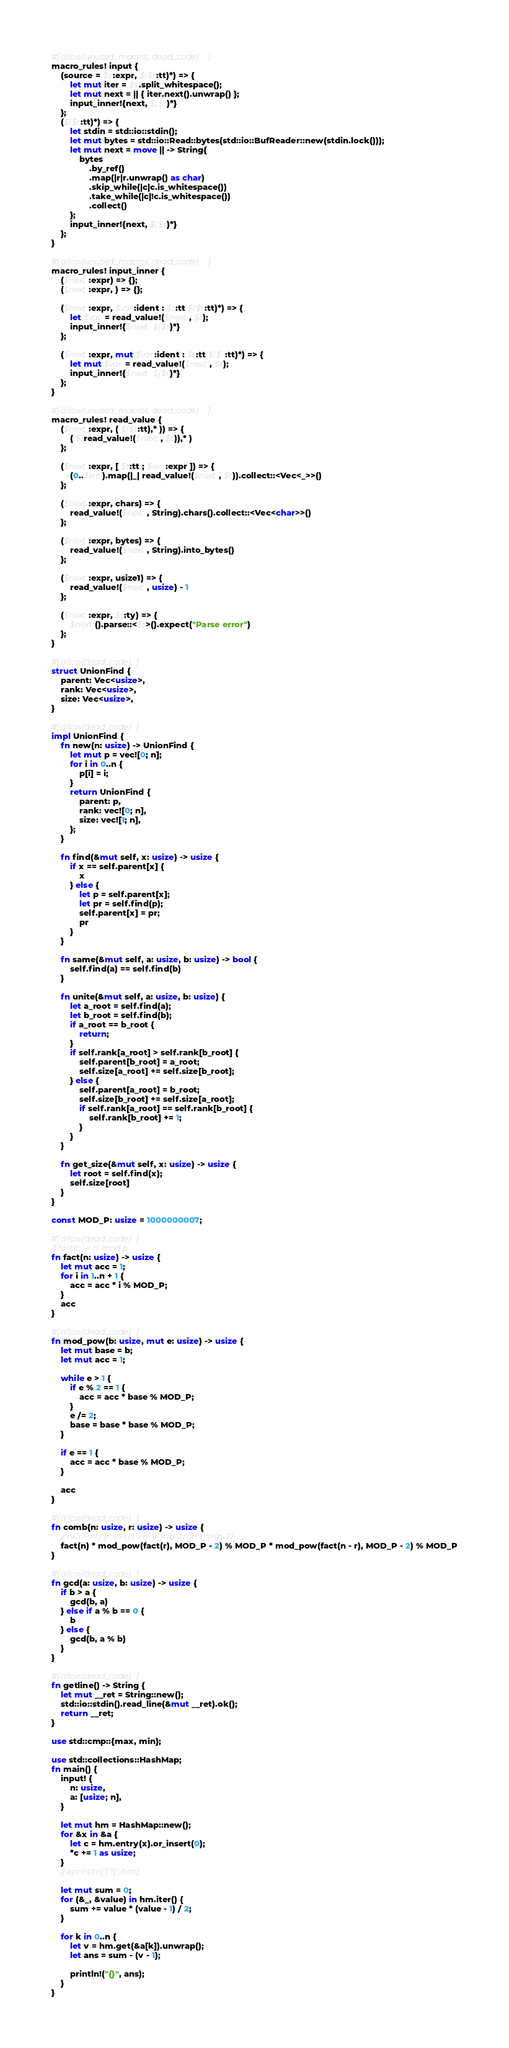Convert code to text. <code><loc_0><loc_0><loc_500><loc_500><_Rust_>#[allow(unused_macros, dead_code)]
macro_rules! input {
    (source = $s:expr, $($r:tt)*) => {
        let mut iter = $s.split_whitespace();
        let mut next = || { iter.next().unwrap() };
        input_inner!{next, $($r)*}
    };
    ($($r:tt)*) => {
        let stdin = std::io::stdin();
        let mut bytes = std::io::Read::bytes(std::io::BufReader::new(stdin.lock()));
        let mut next = move || -> String{
            bytes
                .by_ref()
                .map(|r|r.unwrap() as char)
                .skip_while(|c|c.is_whitespace())
                .take_while(|c|!c.is_whitespace())
                .collect()
        };
        input_inner!{next, $($r)*}
    };
}

#[allow(unused_macros, dead_code)]
macro_rules! input_inner {
    ($next:expr) => {};
    ($next:expr, ) => {};

    ($next:expr, $var:ident : $t:tt $($r:tt)*) => {
        let $var = read_value!($next, $t);
        input_inner!{$next $($r)*}
    };

    ($next:expr, mut $var:ident : $t:tt $($r:tt)*) => {
        let mut $var = read_value!($next, $t);
        input_inner!{$next $($r)*}
    };
}

#[allow(unused_macros, dead_code)]
macro_rules! read_value {
    ($next:expr, ( $($t:tt),* )) => {
        ( $(read_value!($next, $t)),* )
    };

    ($next:expr, [ $t:tt ; $len:expr ]) => {
        (0..$len).map(|_| read_value!($next, $t)).collect::<Vec<_>>()
    };

    ($next:expr, chars) => {
        read_value!($next, String).chars().collect::<Vec<char>>()
    };

    ($next:expr, bytes) => {
        read_value!($next, String).into_bytes()
    };

    ($next:expr, usize1) => {
        read_value!($next, usize) - 1
    };

    ($next:expr, $t:ty) => {
        $next().parse::<$t>().expect("Parse error")
    };
}

#[allow(dead_code)]
struct UnionFind {
    parent: Vec<usize>,
    rank: Vec<usize>,
    size: Vec<usize>,
}

#[allow(dead_code)]
impl UnionFind {
    fn new(n: usize) -> UnionFind {
        let mut p = vec![0; n];
        for i in 0..n {
            p[i] = i;
        }
        return UnionFind {
            parent: p,
            rank: vec![0; n],
            size: vec![1; n],
        };
    }

    fn find(&mut self, x: usize) -> usize {
        if x == self.parent[x] {
            x
        } else {
            let p = self.parent[x];
            let pr = self.find(p);
            self.parent[x] = pr;
            pr
        }
    }

    fn same(&mut self, a: usize, b: usize) -> bool {
        self.find(a) == self.find(b)
    }

    fn unite(&mut self, a: usize, b: usize) {
        let a_root = self.find(a);
        let b_root = self.find(b);
        if a_root == b_root {
            return;
        }
        if self.rank[a_root] > self.rank[b_root] {
            self.parent[b_root] = a_root;
            self.size[a_root] += self.size[b_root];
        } else {
            self.parent[a_root] = b_root;
            self.size[b_root] += self.size[a_root];
            if self.rank[a_root] == self.rank[b_root] {
                self.rank[b_root] += 1;
            }
        }
    }

    fn get_size(&mut self, x: usize) -> usize {
        let root = self.find(x);
        self.size[root]
    }
}

const MOD_P: usize = 1000000007;

#[allow(dead_code)]
// fact(n) = n! mod p
fn fact(n: usize) -> usize {
    let mut acc = 1;
    for i in 1..n + 1 {
        acc = acc * i % MOD_P;
    }
    acc
}

#[allow(dead_code)]
fn mod_pow(b: usize, mut e: usize) -> usize {
    let mut base = b;
    let mut acc = 1;

    while e > 1 {
        if e % 2 == 1 {
            acc = acc * base % MOD_P;
        }
        e /= 2;
        base = base * base % MOD_P;
    }

    if e == 1 {
        acc = acc * base % MOD_P;
    }

    acc
}

#[allow(dead_code)]
fn comb(n: usize, r: usize) -> usize {
    // nCr = n! / (r! (n-r)!) = n! (r!)^(p-2) ((n-r)!)^(p-2)
    fact(n) * mod_pow(fact(r), MOD_P - 2) % MOD_P * mod_pow(fact(n - r), MOD_P - 2) % MOD_P
}

#[allow(dead_code)]
fn gcd(a: usize, b: usize) -> usize {
    if b > a {
        gcd(b, a)
    } else if a % b == 0 {
        b
    } else {
        gcd(b, a % b)
    }
}

#[allow(dead_code)]
fn getline() -> String {
    let mut __ret = String::new();
    std::io::stdin().read_line(&mut __ret).ok();
    return __ret;
}

use std::cmp::{max, min};

use std::collections::HashMap;
fn main() {
    input! {
        n: usize,
        a: [usize; n],
    }

    let mut hm = HashMap::new();
    for &x in &a {
        let c = hm.entry(x).or_insert(0);
        *c += 1 as usize;
    }
    // eprintln!("{:?}", hm);

    let mut sum = 0;
    for (&_, &value) in hm.iter() {
        sum += value * (value - 1) / 2;
    }

    for k in 0..n {
        let v = hm.get(&a[k]).unwrap();
        let ans = sum - (v - 1);

        println!("{}", ans);
    }
}
</code> 